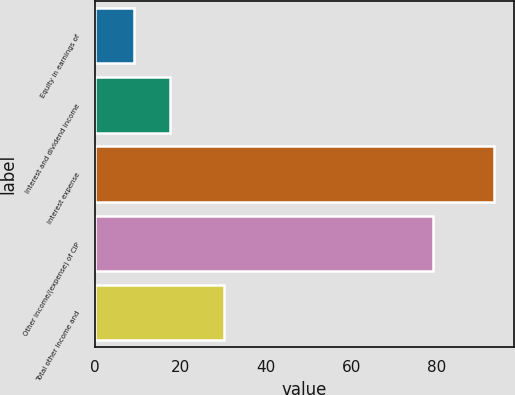Convert chart. <chart><loc_0><loc_0><loc_500><loc_500><bar_chart><fcel>Equity in earnings of<fcel>Interest and dividend income<fcel>Interest expense<fcel>Other income/(expense) of CIP<fcel>Total other income and<nl><fcel>9.3<fcel>17.71<fcel>93.4<fcel>79.2<fcel>30.2<nl></chart> 